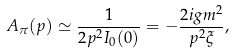<formula> <loc_0><loc_0><loc_500><loc_500>A _ { \pi } ( p ) \simeq \frac { 1 } { 2 p ^ { 2 } I _ { 0 } ( 0 ) } = - \frac { 2 i g m ^ { 2 } } { p ^ { 2 } \xi } ,</formula> 